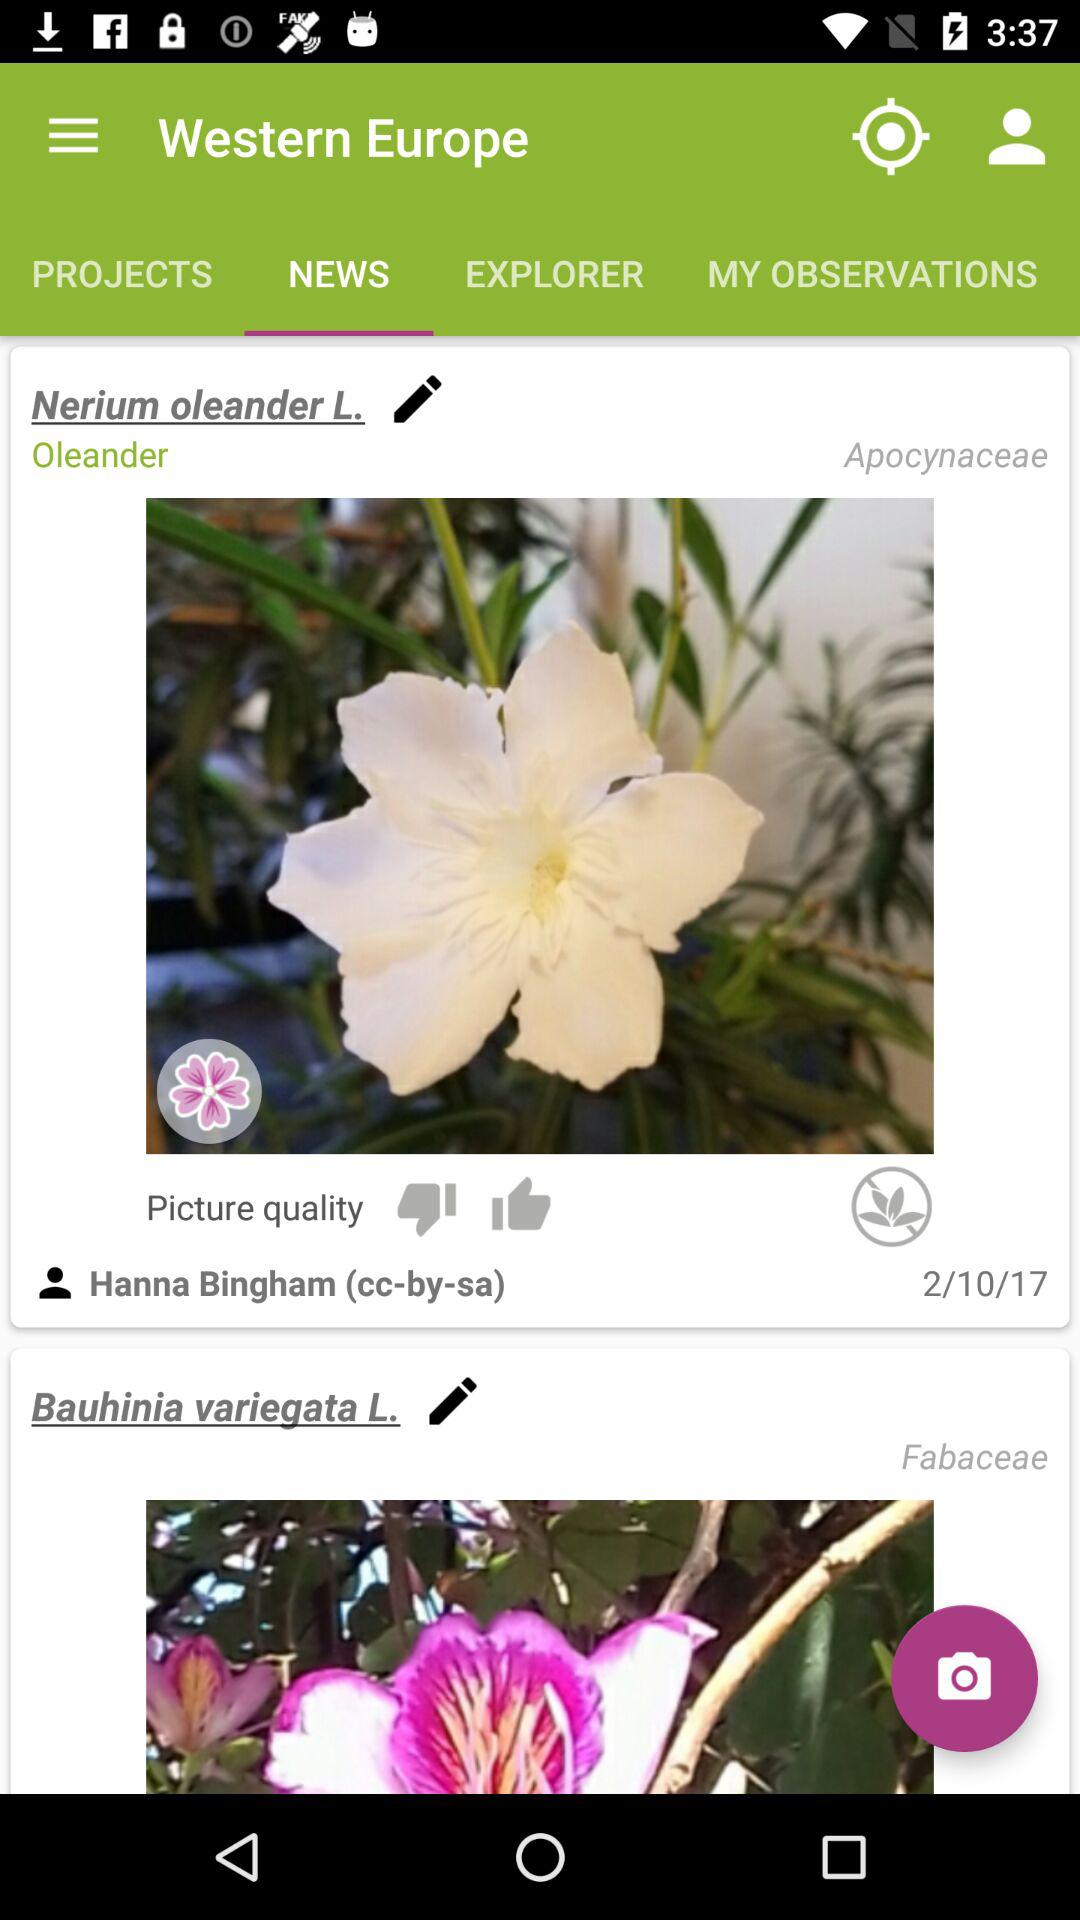What is the scientific name of the first observation?
Answer the question using a single word or phrase. Nerium oleander L. 